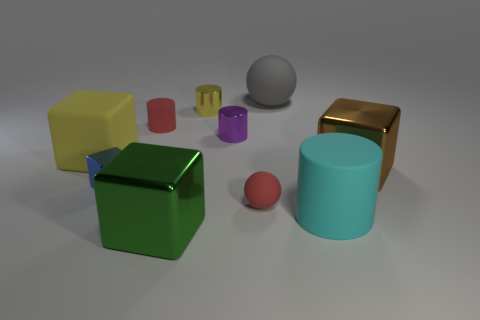Subtract all large cylinders. How many cylinders are left? 3 Subtract all gray balls. How many balls are left? 1 Subtract 1 blocks. How many blocks are left? 3 Subtract all green cylinders. How many blue cubes are left? 1 Subtract all yellow metallic cylinders. Subtract all small blue spheres. How many objects are left? 9 Add 5 shiny cubes. How many shiny cubes are left? 8 Add 1 yellow rubber objects. How many yellow rubber objects exist? 2 Subtract 0 brown spheres. How many objects are left? 10 Subtract all cubes. How many objects are left? 6 Subtract all cyan cylinders. Subtract all blue spheres. How many cylinders are left? 3 